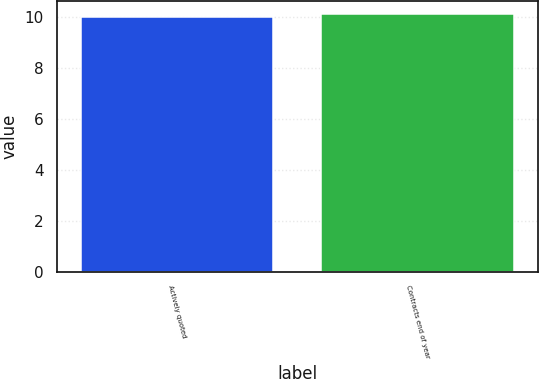<chart> <loc_0><loc_0><loc_500><loc_500><bar_chart><fcel>Actively quoted<fcel>Contracts end of year<nl><fcel>10<fcel>10.1<nl></chart> 